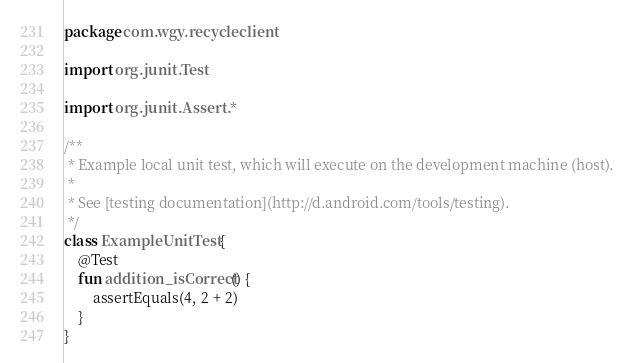<code> <loc_0><loc_0><loc_500><loc_500><_Kotlin_>package com.wgy.recycleclient

import org.junit.Test

import org.junit.Assert.*

/**
 * Example local unit test, which will execute on the development machine (host).
 *
 * See [testing documentation](http://d.android.com/tools/testing).
 */
class ExampleUnitTest {
    @Test
    fun addition_isCorrect() {
        assertEquals(4, 2 + 2)
    }
}</code> 